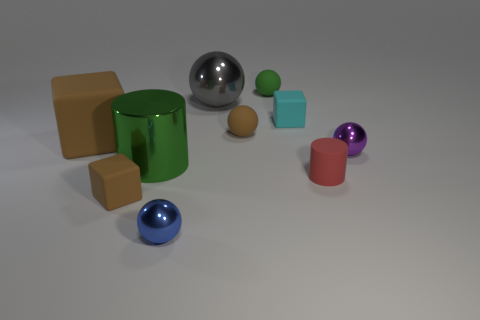Subtract all cyan balls. Subtract all purple cubes. How many balls are left? 5 Subtract all blocks. How many objects are left? 7 Subtract 0 cyan balls. How many objects are left? 10 Subtract all large cyan blocks. Subtract all tiny brown matte objects. How many objects are left? 8 Add 2 gray shiny things. How many gray shiny things are left? 3 Add 5 tiny green things. How many tiny green things exist? 6 